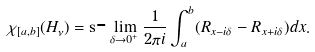Convert formula to latex. <formula><loc_0><loc_0><loc_500><loc_500>\chi _ { [ a , b ] } ( H _ { \nu } ) = { \mathrm s } \text  -\lim_{\delta\to 0^{+}} \frac { 1 } { 2 \pi i } \int _ { a } ^ { b } ( R _ { x - i \delta } - R _ { x + i \delta } ) d x .</formula> 